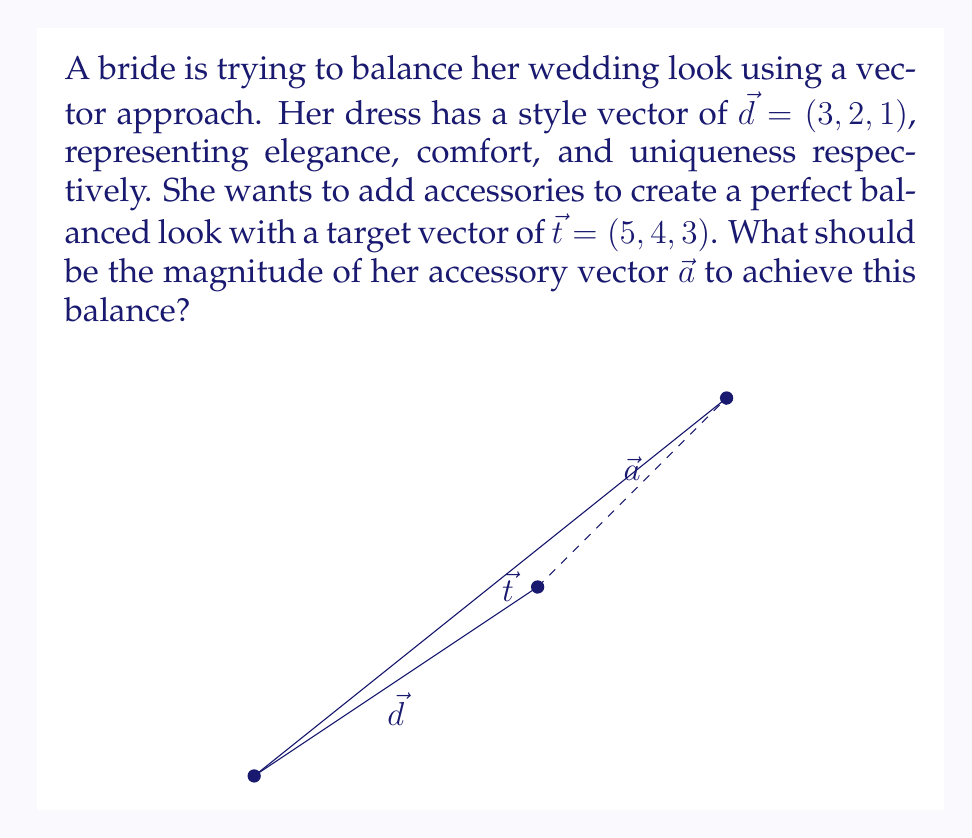What is the answer to this math problem? Let's approach this step-by-step:

1) We know that $\vec{t} = \vec{d} + \vec{a}$

2) Therefore, $\vec{a} = \vec{t} - \vec{d}$

3) Let's calculate $\vec{a}$:
   $\vec{a} = (5, 4, 3) - (3, 2, 1) = (2, 2, 2)$

4) To find the magnitude of $\vec{a}$, we use the formula:
   $|\vec{a}| = \sqrt{a_x^2 + a_y^2 + a_z^2}$

5) Substituting our values:
   $|\vec{a}| = \sqrt{2^2 + 2^2 + 2^2}$

6) Simplify:
   $|\vec{a}| = \sqrt{4 + 4 + 4} = \sqrt{12}$

7) Simplify further:
   $|\vec{a}| = 2\sqrt{3}$

Thus, the magnitude of the accessory vector should be $2\sqrt{3}$ to balance the overall look.
Answer: $2\sqrt{3}$ 